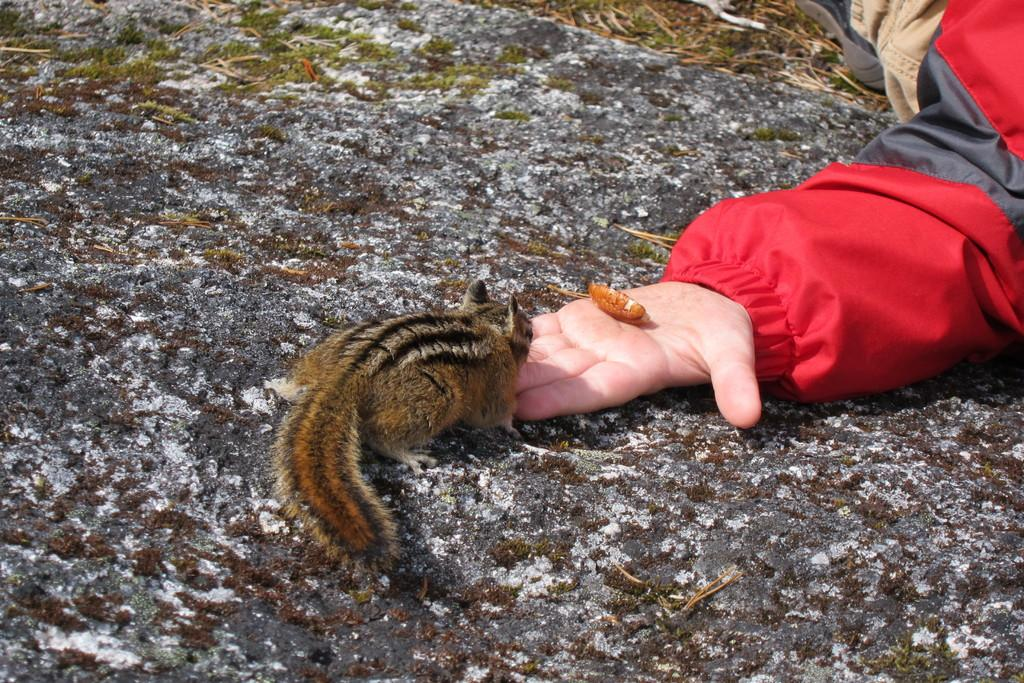Who or what is on the right side of the image? There is a person on the right side of the image. What is the person holding in their hand? The person is holding a squirrel in their hand. What is the person wearing? The person is wearing a red jacket. What type of alarm can be heard going off in the image? There is no alarm present in the image, and therefore no sound can be heard. 